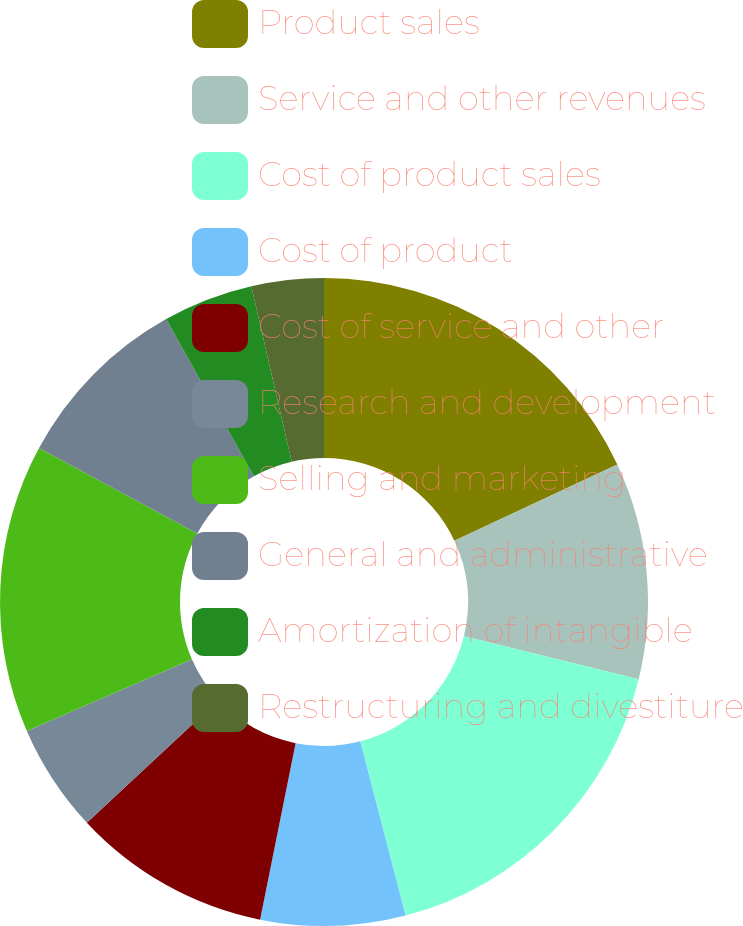<chart> <loc_0><loc_0><loc_500><loc_500><pie_chart><fcel>Product sales<fcel>Service and other revenues<fcel>Cost of product sales<fcel>Cost of product<fcel>Cost of service and other<fcel>Research and development<fcel>Selling and marketing<fcel>General and administrative<fcel>Amortization of intangible<fcel>Restructuring and divestiture<nl><fcel>18.02%<fcel>10.81%<fcel>17.12%<fcel>7.21%<fcel>9.91%<fcel>5.41%<fcel>14.41%<fcel>9.01%<fcel>4.5%<fcel>3.6%<nl></chart> 